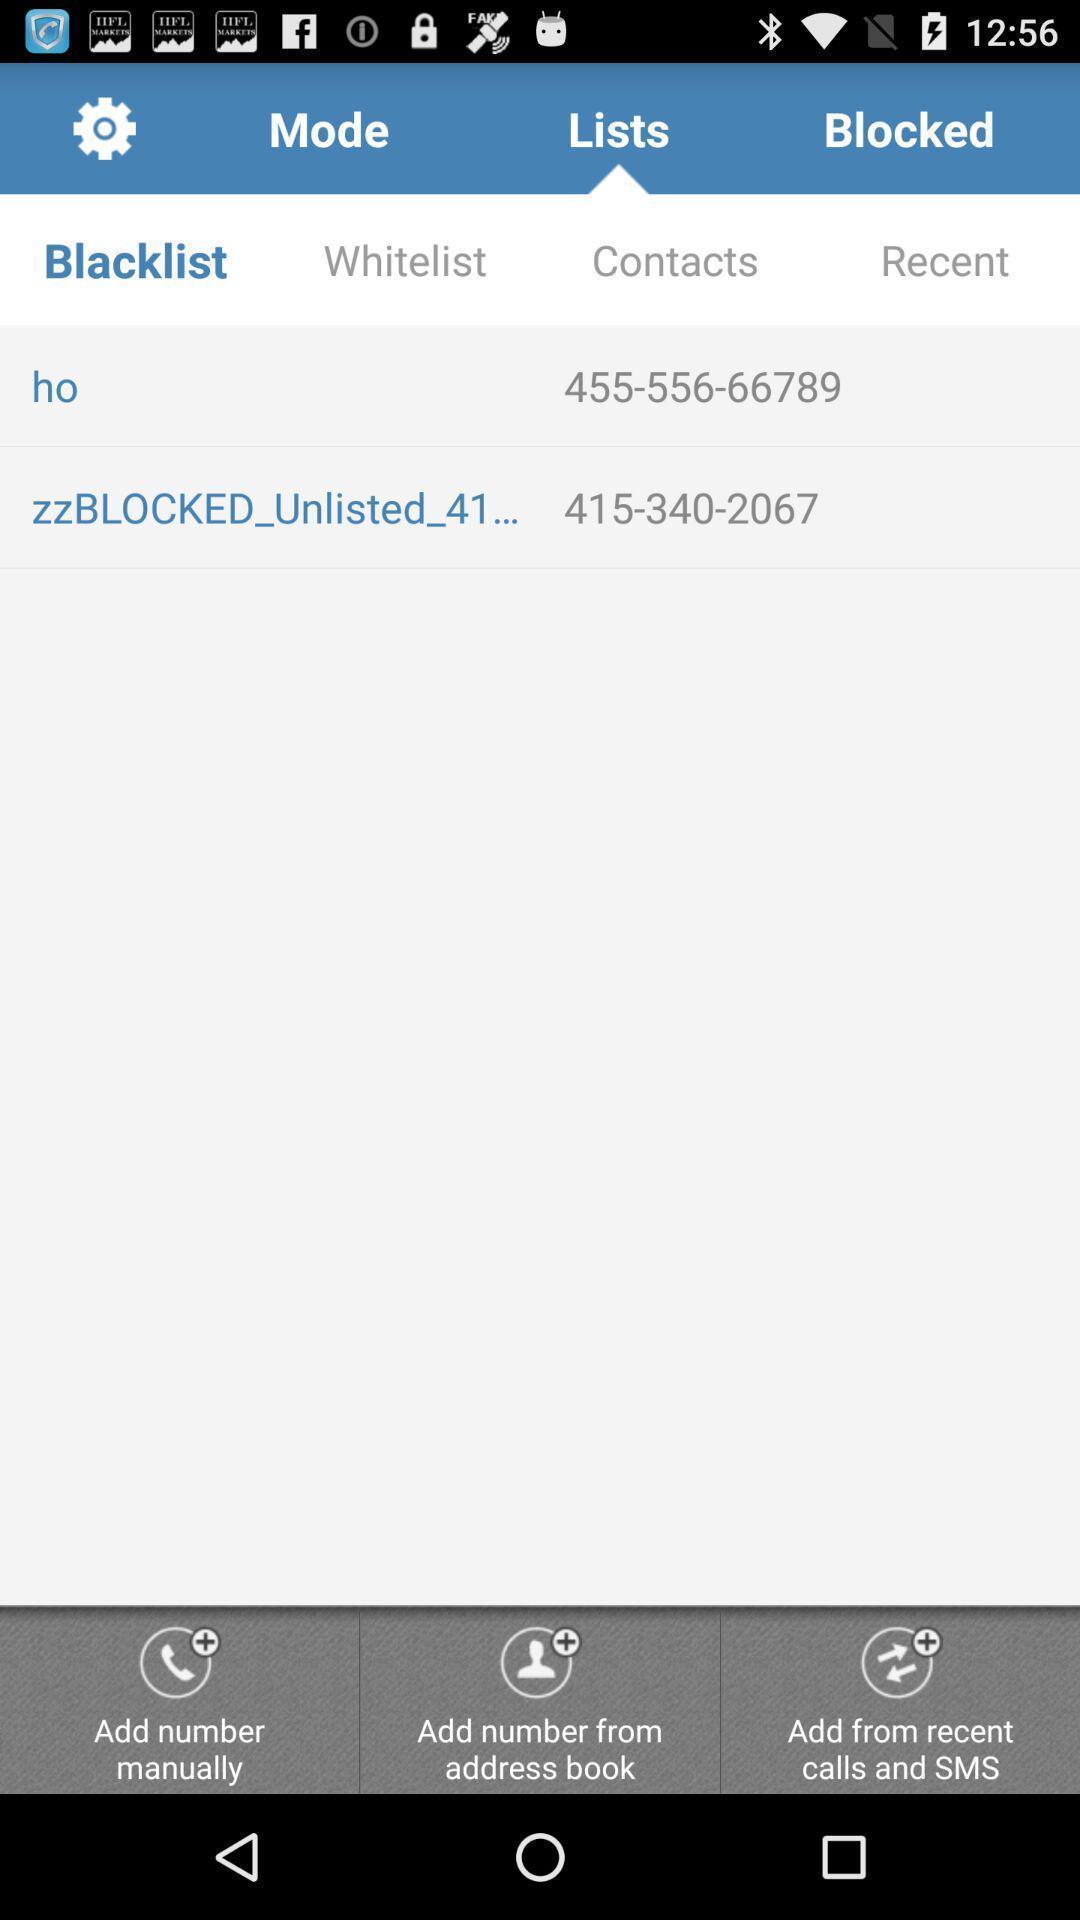What can you discern from this picture? Two contacts are displaying under blacklists. 